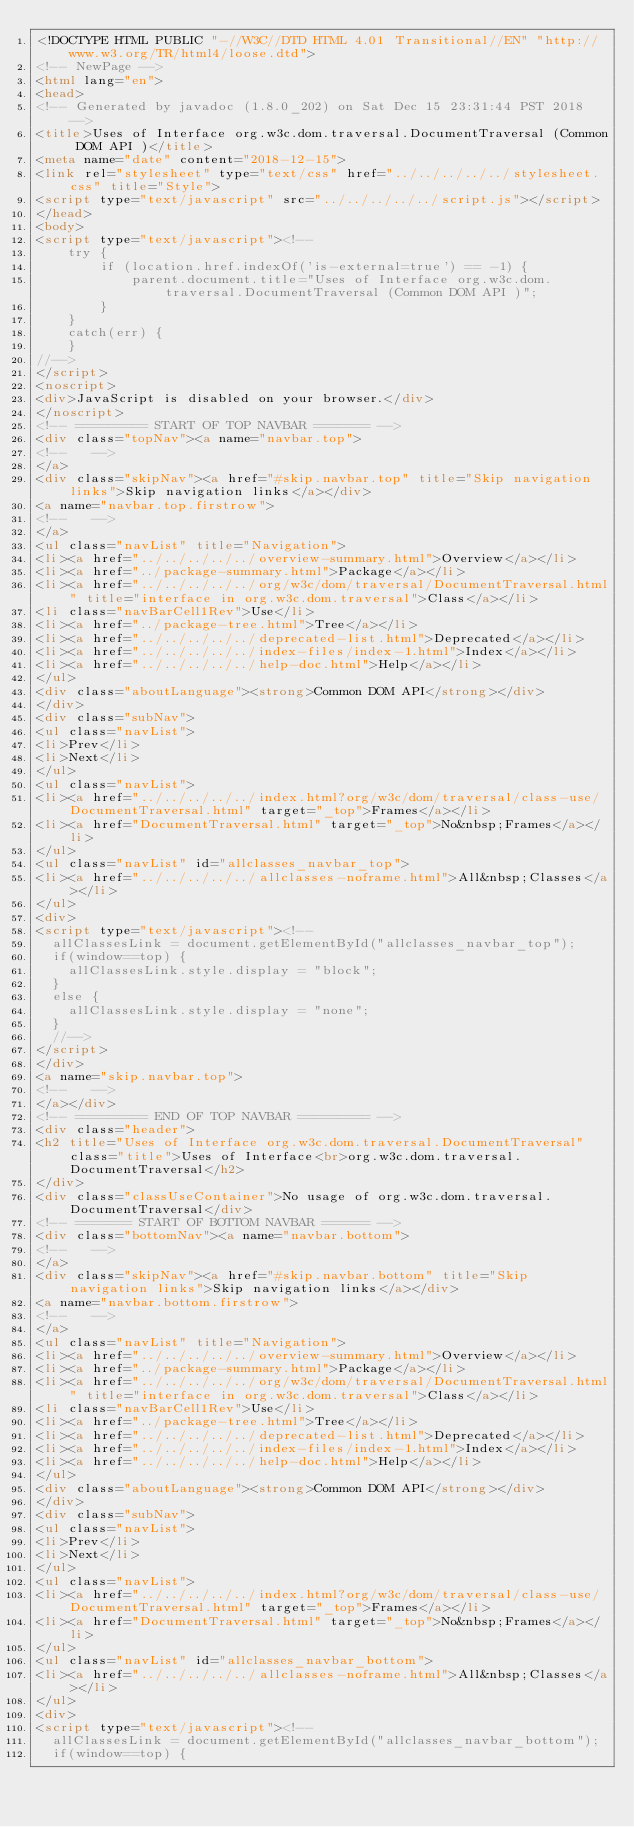Convert code to text. <code><loc_0><loc_0><loc_500><loc_500><_HTML_><!DOCTYPE HTML PUBLIC "-//W3C//DTD HTML 4.01 Transitional//EN" "http://www.w3.org/TR/html4/loose.dtd">
<!-- NewPage -->
<html lang="en">
<head>
<!-- Generated by javadoc (1.8.0_202) on Sat Dec 15 23:31:44 PST 2018 -->
<title>Uses of Interface org.w3c.dom.traversal.DocumentTraversal (Common DOM API )</title>
<meta name="date" content="2018-12-15">
<link rel="stylesheet" type="text/css" href="../../../../../stylesheet.css" title="Style">
<script type="text/javascript" src="../../../../../script.js"></script>
</head>
<body>
<script type="text/javascript"><!--
    try {
        if (location.href.indexOf('is-external=true') == -1) {
            parent.document.title="Uses of Interface org.w3c.dom.traversal.DocumentTraversal (Common DOM API )";
        }
    }
    catch(err) {
    }
//-->
</script>
<noscript>
<div>JavaScript is disabled on your browser.</div>
</noscript>
<!-- ========= START OF TOP NAVBAR ======= -->
<div class="topNav"><a name="navbar.top">
<!--   -->
</a>
<div class="skipNav"><a href="#skip.navbar.top" title="Skip navigation links">Skip navigation links</a></div>
<a name="navbar.top.firstrow">
<!--   -->
</a>
<ul class="navList" title="Navigation">
<li><a href="../../../../../overview-summary.html">Overview</a></li>
<li><a href="../package-summary.html">Package</a></li>
<li><a href="../../../../../org/w3c/dom/traversal/DocumentTraversal.html" title="interface in org.w3c.dom.traversal">Class</a></li>
<li class="navBarCell1Rev">Use</li>
<li><a href="../package-tree.html">Tree</a></li>
<li><a href="../../../../../deprecated-list.html">Deprecated</a></li>
<li><a href="../../../../../index-files/index-1.html">Index</a></li>
<li><a href="../../../../../help-doc.html">Help</a></li>
</ul>
<div class="aboutLanguage"><strong>Common DOM API</strong></div>
</div>
<div class="subNav">
<ul class="navList">
<li>Prev</li>
<li>Next</li>
</ul>
<ul class="navList">
<li><a href="../../../../../index.html?org/w3c/dom/traversal/class-use/DocumentTraversal.html" target="_top">Frames</a></li>
<li><a href="DocumentTraversal.html" target="_top">No&nbsp;Frames</a></li>
</ul>
<ul class="navList" id="allclasses_navbar_top">
<li><a href="../../../../../allclasses-noframe.html">All&nbsp;Classes</a></li>
</ul>
<div>
<script type="text/javascript"><!--
  allClassesLink = document.getElementById("allclasses_navbar_top");
  if(window==top) {
    allClassesLink.style.display = "block";
  }
  else {
    allClassesLink.style.display = "none";
  }
  //-->
</script>
</div>
<a name="skip.navbar.top">
<!--   -->
</a></div>
<!-- ========= END OF TOP NAVBAR ========= -->
<div class="header">
<h2 title="Uses of Interface org.w3c.dom.traversal.DocumentTraversal" class="title">Uses of Interface<br>org.w3c.dom.traversal.DocumentTraversal</h2>
</div>
<div class="classUseContainer">No usage of org.w3c.dom.traversal.DocumentTraversal</div>
<!-- ======= START OF BOTTOM NAVBAR ====== -->
<div class="bottomNav"><a name="navbar.bottom">
<!--   -->
</a>
<div class="skipNav"><a href="#skip.navbar.bottom" title="Skip navigation links">Skip navigation links</a></div>
<a name="navbar.bottom.firstrow">
<!--   -->
</a>
<ul class="navList" title="Navigation">
<li><a href="../../../../../overview-summary.html">Overview</a></li>
<li><a href="../package-summary.html">Package</a></li>
<li><a href="../../../../../org/w3c/dom/traversal/DocumentTraversal.html" title="interface in org.w3c.dom.traversal">Class</a></li>
<li class="navBarCell1Rev">Use</li>
<li><a href="../package-tree.html">Tree</a></li>
<li><a href="../../../../../deprecated-list.html">Deprecated</a></li>
<li><a href="../../../../../index-files/index-1.html">Index</a></li>
<li><a href="../../../../../help-doc.html">Help</a></li>
</ul>
<div class="aboutLanguage"><strong>Common DOM API</strong></div>
</div>
<div class="subNav">
<ul class="navList">
<li>Prev</li>
<li>Next</li>
</ul>
<ul class="navList">
<li><a href="../../../../../index.html?org/w3c/dom/traversal/class-use/DocumentTraversal.html" target="_top">Frames</a></li>
<li><a href="DocumentTraversal.html" target="_top">No&nbsp;Frames</a></li>
</ul>
<ul class="navList" id="allclasses_navbar_bottom">
<li><a href="../../../../../allclasses-noframe.html">All&nbsp;Classes</a></li>
</ul>
<div>
<script type="text/javascript"><!--
  allClassesLink = document.getElementById("allclasses_navbar_bottom");
  if(window==top) {</code> 